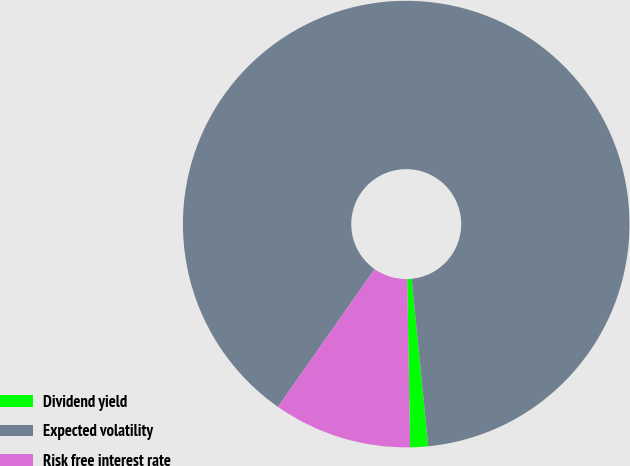Convert chart to OTSL. <chart><loc_0><loc_0><loc_500><loc_500><pie_chart><fcel>Dividend yield<fcel>Expected volatility<fcel>Risk free interest rate<nl><fcel>1.29%<fcel>88.69%<fcel>10.02%<nl></chart> 